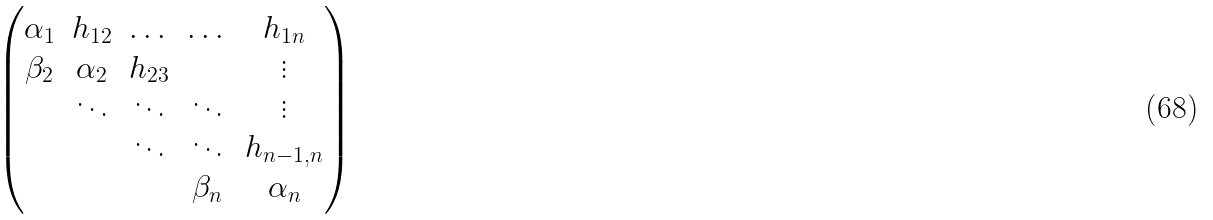Convert formula to latex. <formula><loc_0><loc_0><loc_500><loc_500>\begin{pmatrix} \alpha _ { 1 } & h _ { 1 2 } & \dots & \dots & h _ { 1 n } \\ \beta _ { 2 } & \alpha _ { 2 } & h _ { 2 3 } & & \vdots \\ & \ddots & \ddots & \ddots & \vdots \\ & & \ddots & \ddots & h _ { n - 1 , n } \\ & & & \beta _ { n } & \alpha _ { n } \end{pmatrix}</formula> 